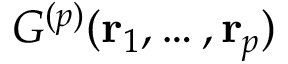Convert formula to latex. <formula><loc_0><loc_0><loc_500><loc_500>G ^ { ( p ) } ( { r } _ { 1 } , \dots , { r } _ { p } )</formula> 